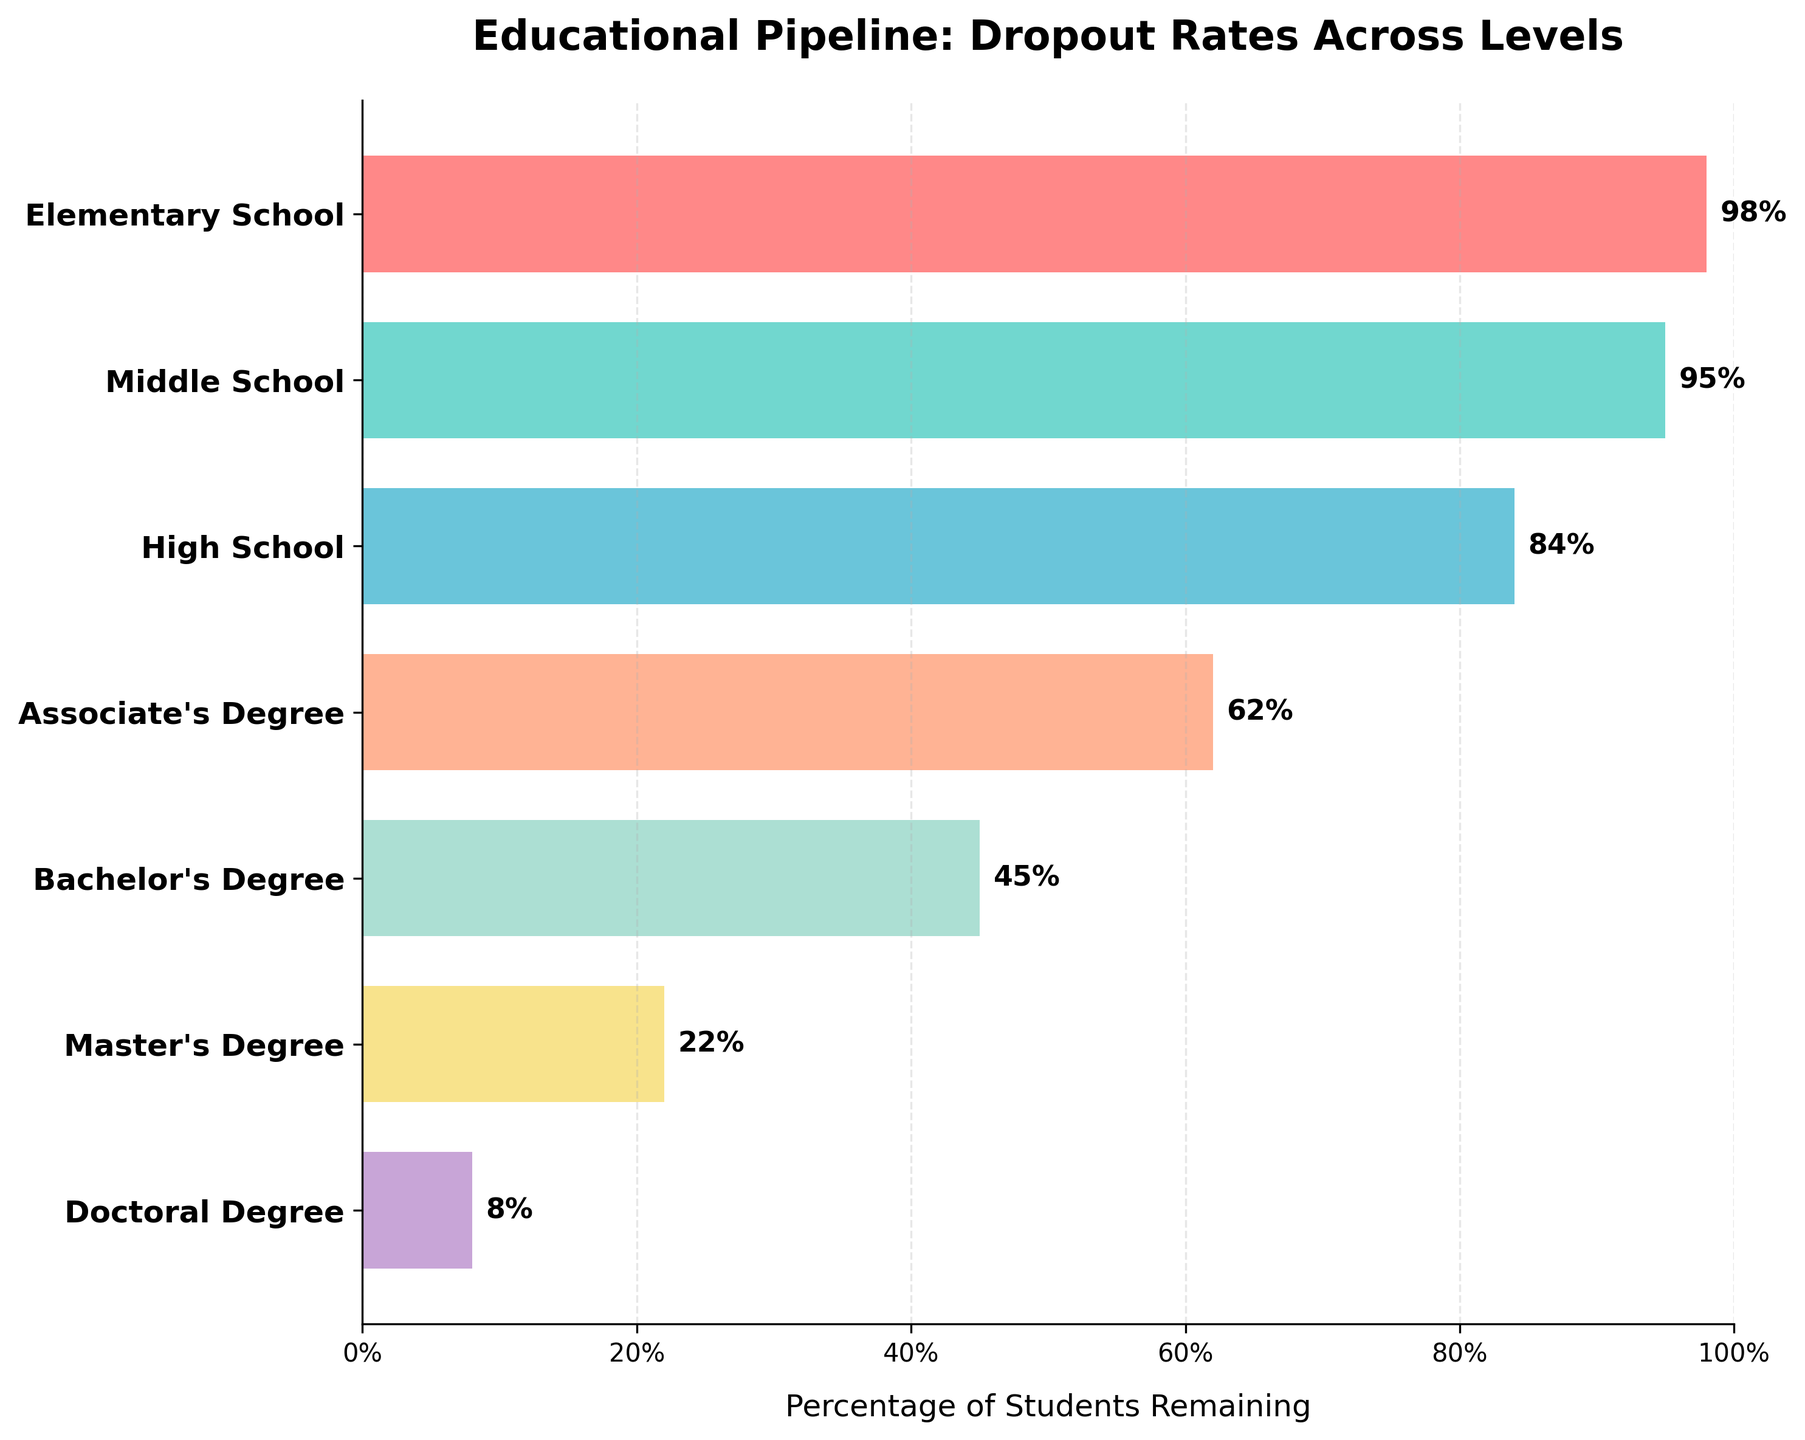what is the title of the figure? The title is located at the top of the chart and provides a quick summary of the data. The title is "Educational Pipeline: Dropout Rates Across Levels".
Answer: Educational Pipeline: Dropout Rates Across Levels what is the percentage of students who remain in elementary school? The 'Elementary School' bar shows the percentage of students retained. The bar label indicates 98%.
Answer: 98% how many educational stages are represented in this funnel chart? The y-axis lists all the educational stages. Counting them shows there are seven stages.
Answer: 7 what is the lowest percentage of students remaining in an educational stage? By examining the percentages labeled on the bars, the lowest percentage visible is for the 'Doctoral Degree'.
Answer: 8% how do dropout rates change from high school to an associate's degree? The percentage for 'High School' is 84%, and for 'Associate's Degree' it is 62%. Subtracting these shows a decline of 22%.
Answer: Decrease by 22% which educational stage has the most significant drop in percentage from the previous stage? Comparing the differences from one stage to another, the drop from 'Master's Degree' (22%) to 'Doctoral Degree' (8%) is the largest with a decrease of 14%.
Answer: From Master's Degree to Doctoral Degree what percentage of students remain from an associate's degree level to a bachelor's degree level? The funnel chart shows 62% remain at the 'Associate's Degree' level and 45% at the 'Bachelor’s Degree' level. Calculating the percentage difference is 17%.
Answer: 17% which educational level sees a reduction to less than half of the students from the previous level? The chart indicates a drop from 'Bachelor's Degree' (45%) to 'Master's Degree' (22%), which is less than half (22% < 45%/2).
Answer: Master's Degree what is the average percentage of students remaining from high school to a doctoral degree? The stages from 'High School' to 'Doctoral Degree' are 84%, 62%, 45%, 22%, and 8%. Summing these and dividing by 5 yields: (84 + 62 + 45 + 22 + 8)/5 = 44.2%.
Answer: 44.2% how much more percentage of students remain at the middle school level compared to the bachelor's degree level? The chart shows 'Middle School' has 95% and 'Bachelor's Degree' 45%. The difference is 95% - 45% = 50%.
Answer: 50% 